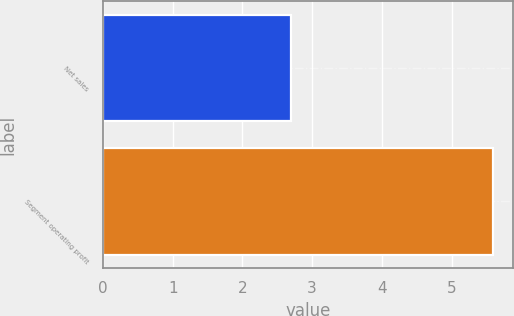<chart> <loc_0><loc_0><loc_500><loc_500><bar_chart><fcel>Net sales<fcel>Segment operating profit<nl><fcel>2.7<fcel>5.6<nl></chart> 